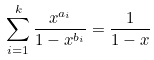Convert formula to latex. <formula><loc_0><loc_0><loc_500><loc_500>\sum _ { i = 1 } ^ { k } \frac { x ^ { a _ { i } } } { 1 - x ^ { b _ { i } } } = \frac { 1 } { 1 - x }</formula> 